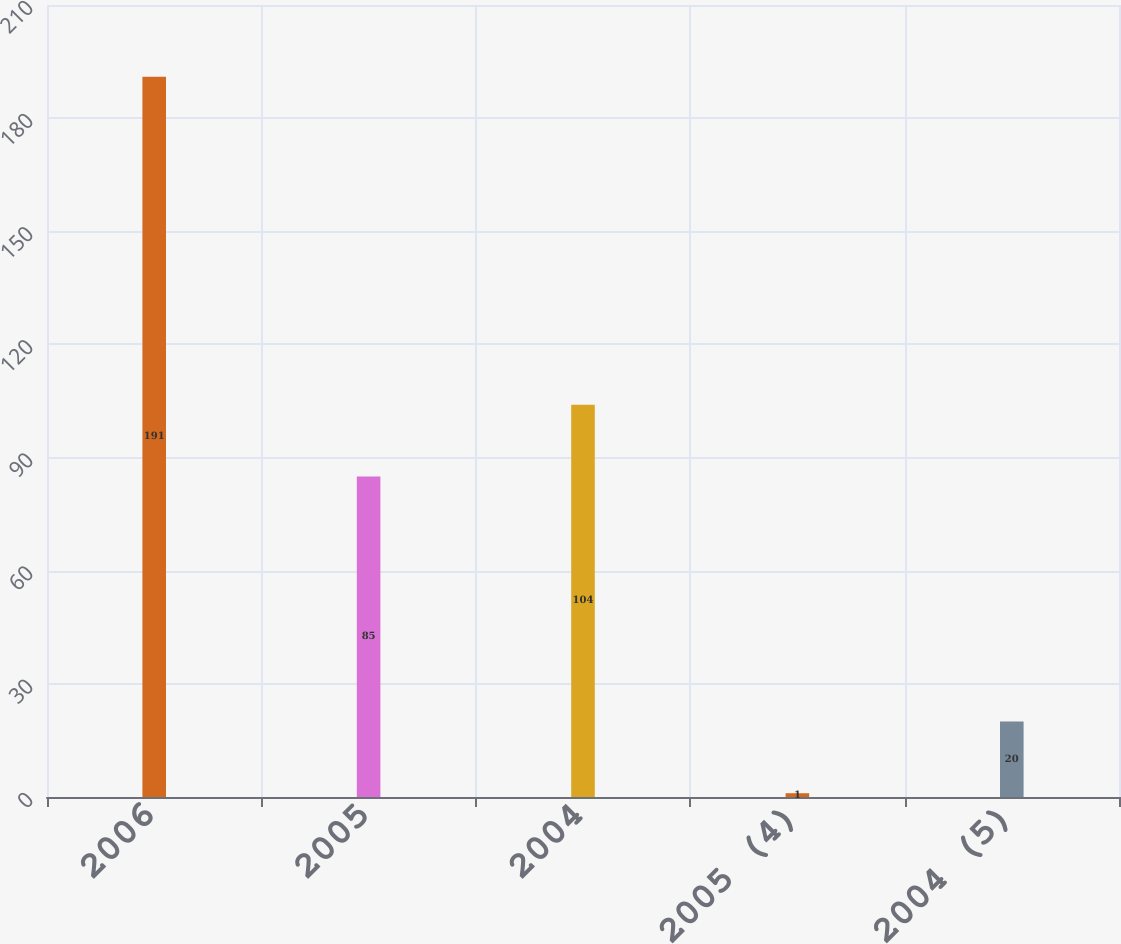<chart> <loc_0><loc_0><loc_500><loc_500><bar_chart><fcel>2006<fcel>2005<fcel>2004<fcel>2005 (4)<fcel>2004 (5)<nl><fcel>191<fcel>85<fcel>104<fcel>1<fcel>20<nl></chart> 